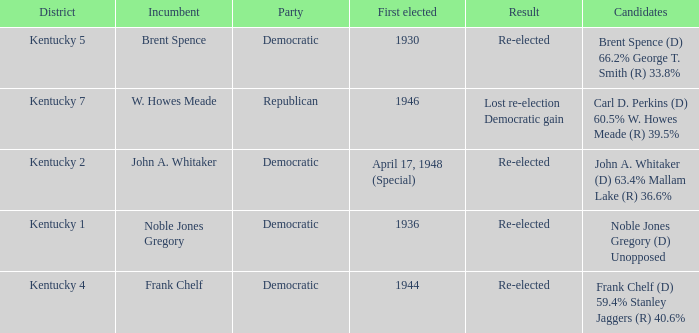What was the result in the voting district Kentucky 2? Re-elected. 